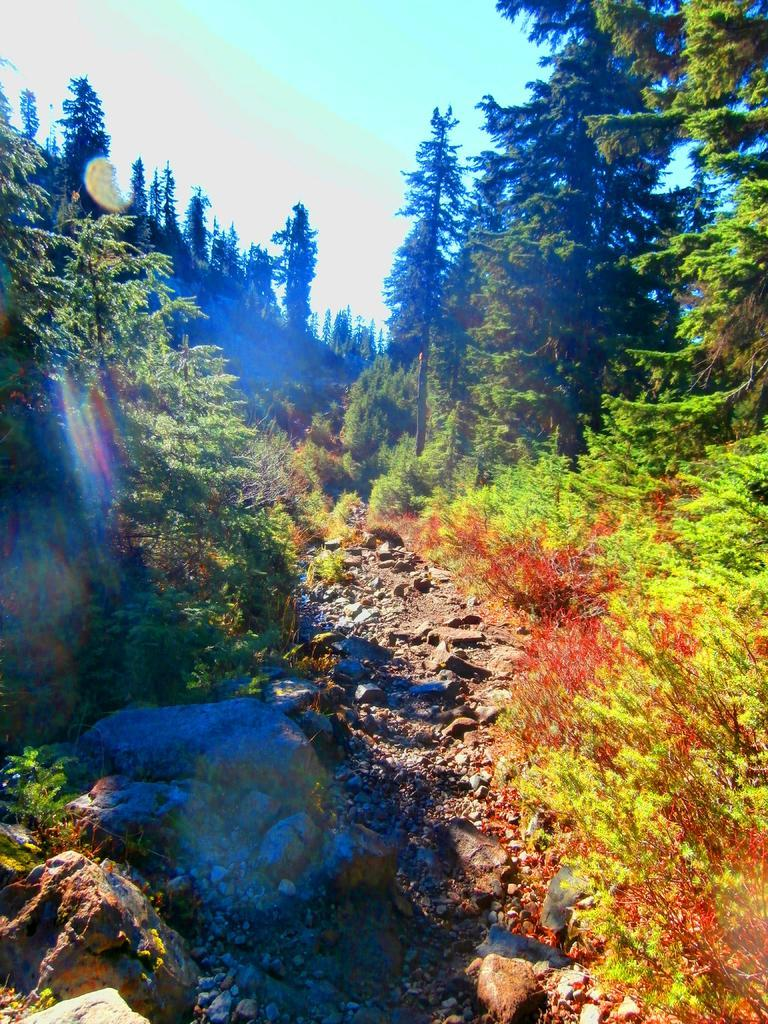What type of vegetation can be seen in the image? There are trees in the image. What other objects are present in the image? There are stones in the image. What is visible in the background of the image? The sky is visible in the image. How many fish can be seen swimming in the image? There are no fish present in the image. What type of fabric is used to make the quilt in the image? There is no quilt present in the image. 